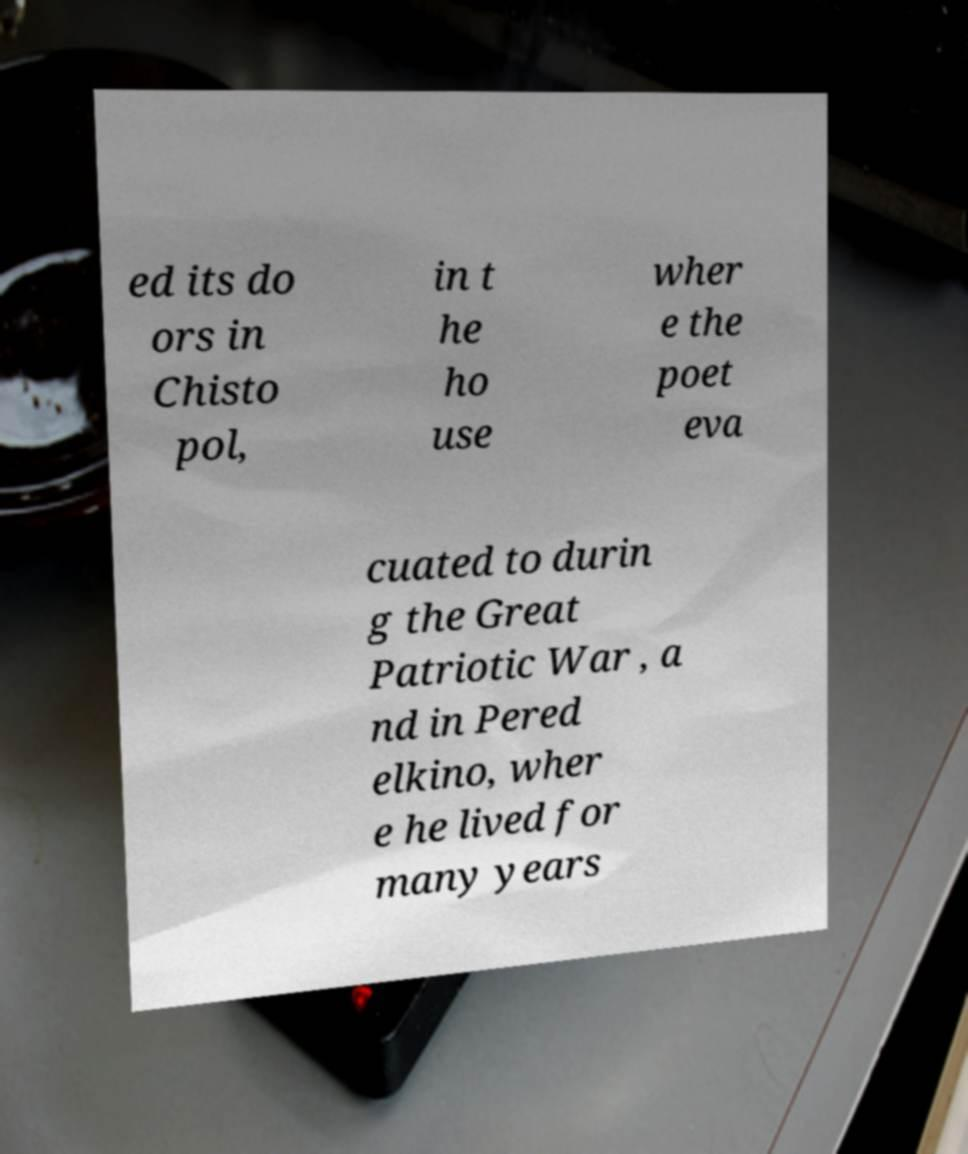Could you assist in decoding the text presented in this image and type it out clearly? ed its do ors in Chisto pol, in t he ho use wher e the poet eva cuated to durin g the Great Patriotic War , a nd in Pered elkino, wher e he lived for many years 